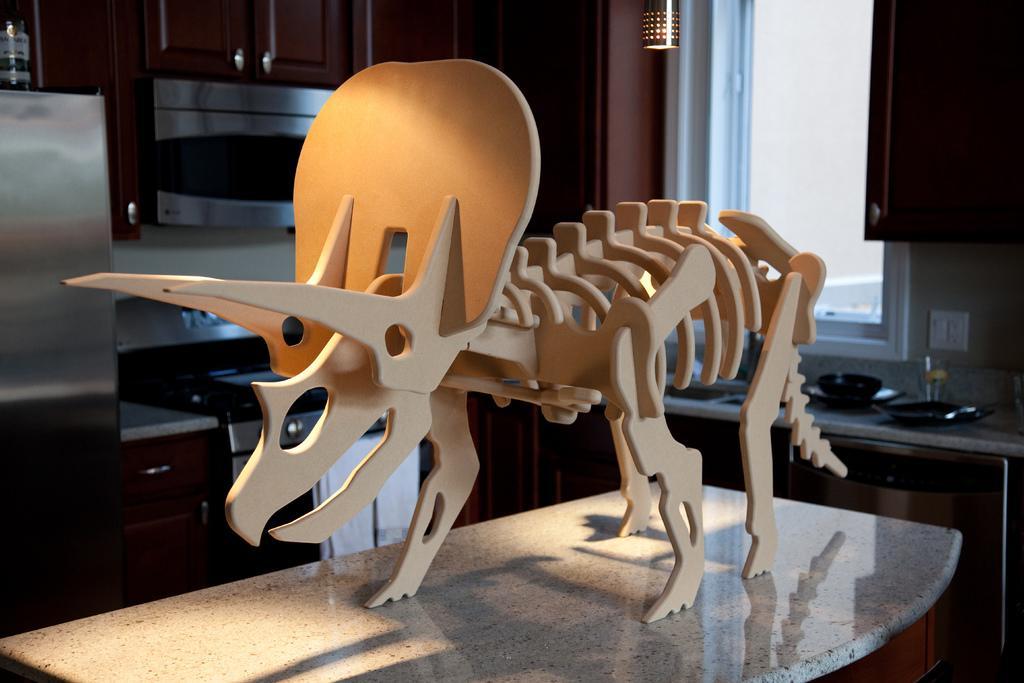Please provide a concise description of this image. In this image I can see skeleton, platform, cupboards, window, light and objects. 